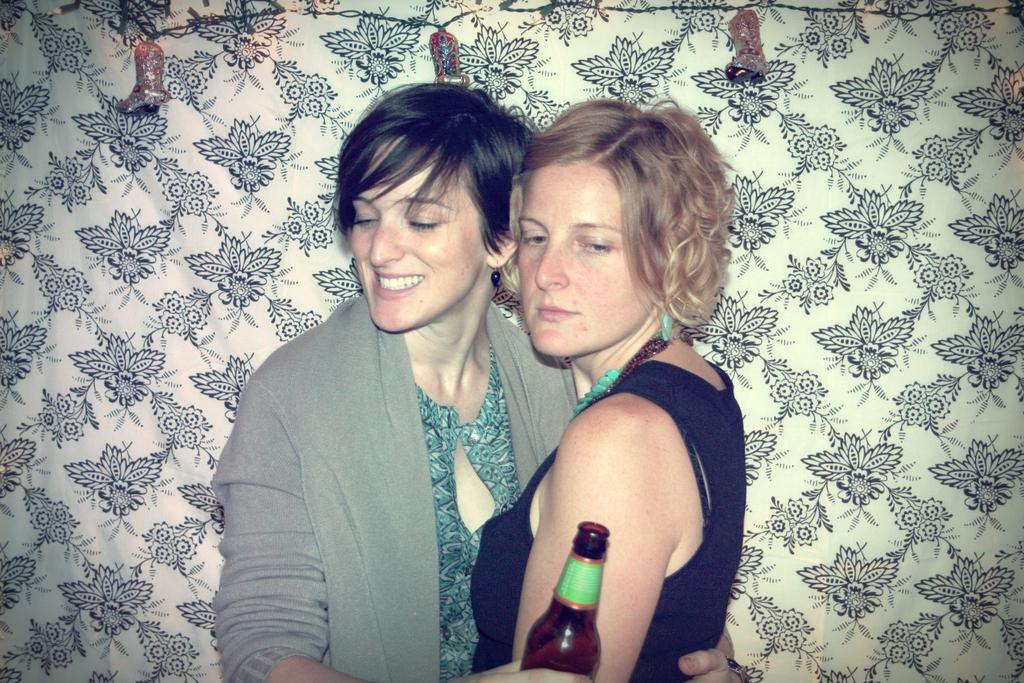How many people are in the image? There are two persons in the image. What are the two persons doing? The two persons are holding each other. What is one person holding in addition to the other person? One person is holding a bottle. What can be seen in the background of the image? There is a wall and lights visible in the background. What type of vegetable is being used as a board in the image? There is no vegetable being used as a board in the image. How much wax is visible on the persons in the image? There is no wax visible on the persons in the image. 